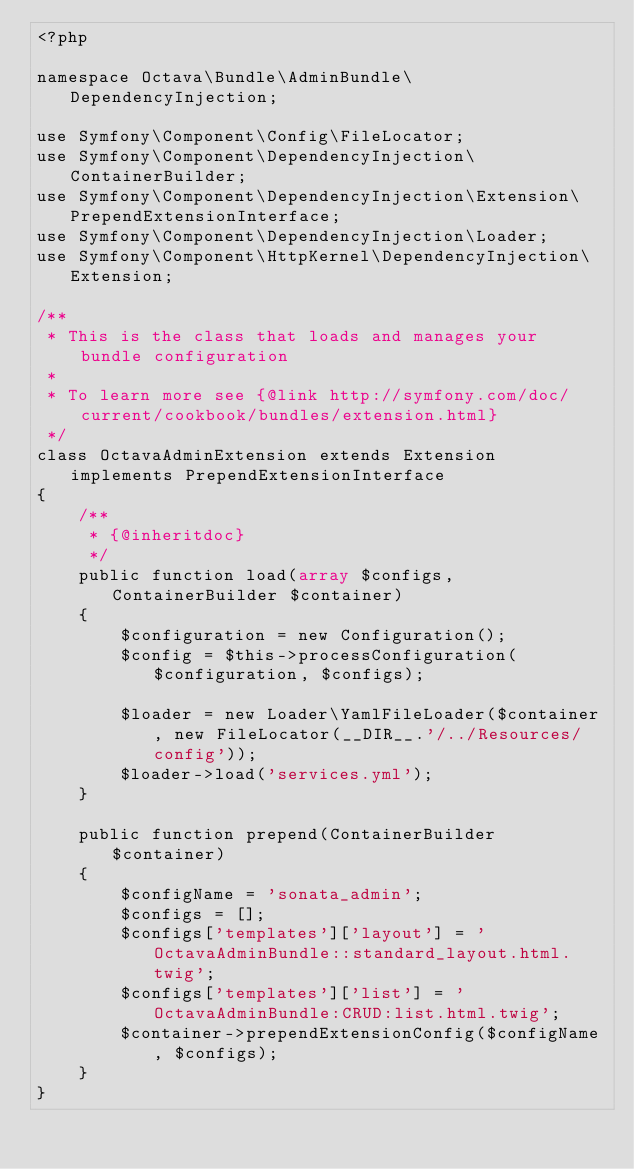<code> <loc_0><loc_0><loc_500><loc_500><_PHP_><?php

namespace Octava\Bundle\AdminBundle\DependencyInjection;

use Symfony\Component\Config\FileLocator;
use Symfony\Component\DependencyInjection\ContainerBuilder;
use Symfony\Component\DependencyInjection\Extension\PrependExtensionInterface;
use Symfony\Component\DependencyInjection\Loader;
use Symfony\Component\HttpKernel\DependencyInjection\Extension;

/**
 * This is the class that loads and manages your bundle configuration
 *
 * To learn more see {@link http://symfony.com/doc/current/cookbook/bundles/extension.html}
 */
class OctavaAdminExtension extends Extension implements PrependExtensionInterface
{
    /**
     * {@inheritdoc}
     */
    public function load(array $configs, ContainerBuilder $container)
    {
        $configuration = new Configuration();
        $config = $this->processConfiguration($configuration, $configs);

        $loader = new Loader\YamlFileLoader($container, new FileLocator(__DIR__.'/../Resources/config'));
        $loader->load('services.yml');
    }

    public function prepend(ContainerBuilder $container)
    {
        $configName = 'sonata_admin';
        $configs = [];
        $configs['templates']['layout'] = 'OctavaAdminBundle::standard_layout.html.twig';
        $configs['templates']['list'] = 'OctavaAdminBundle:CRUD:list.html.twig';
        $container->prependExtensionConfig($configName, $configs);
    }
}
</code> 